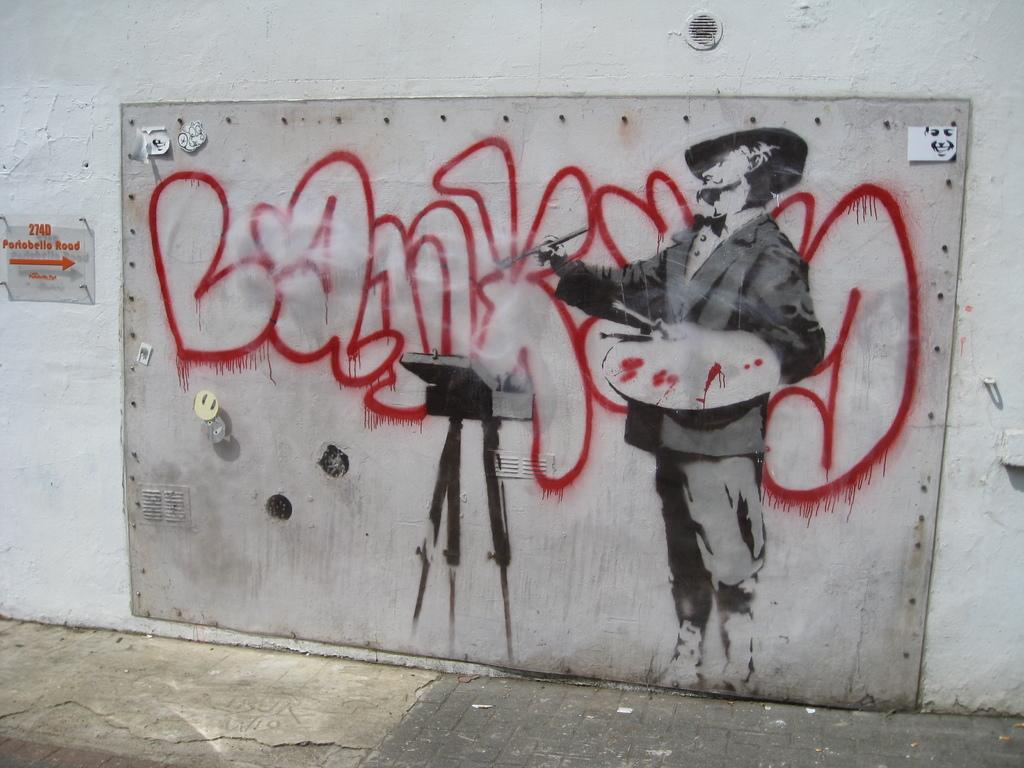What is hanging on the wall in the image? There is a painting on the wall in the image. What object with text can be seen in the image? There is a glass board with text in the image. How many holes can be seen in the painting in the image? There are no holes visible in the painting in the image. What type of regret is depicted in the painting in the image? There is no depiction of regret in the painting in the image. 